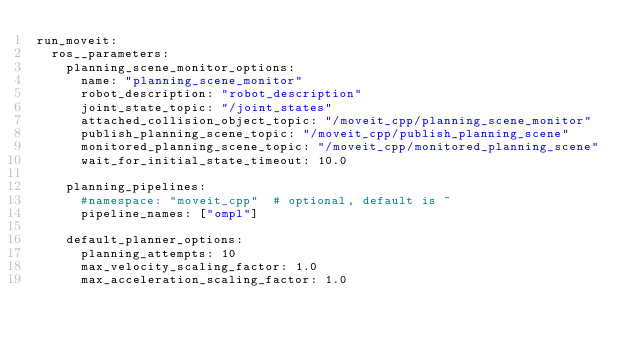<code> <loc_0><loc_0><loc_500><loc_500><_YAML_>run_moveit:
  ros__parameters:
    planning_scene_monitor_options:
      name: "planning_scene_monitor"
      robot_description: "robot_description"
      joint_state_topic: "/joint_states"
      attached_collision_object_topic: "/moveit_cpp/planning_scene_monitor"
      publish_planning_scene_topic: "/moveit_cpp/publish_planning_scene"
      monitored_planning_scene_topic: "/moveit_cpp/monitored_planning_scene"
      wait_for_initial_state_timeout: 10.0
    
    planning_pipelines:
      #namespace: "moveit_cpp"  # optional, default is ~
      pipeline_names: ["ompl"]
    
    default_planner_options:
      planning_attempts: 10
      max_velocity_scaling_factor: 1.0
      max_acceleration_scaling_factor: 1.0 
</code> 